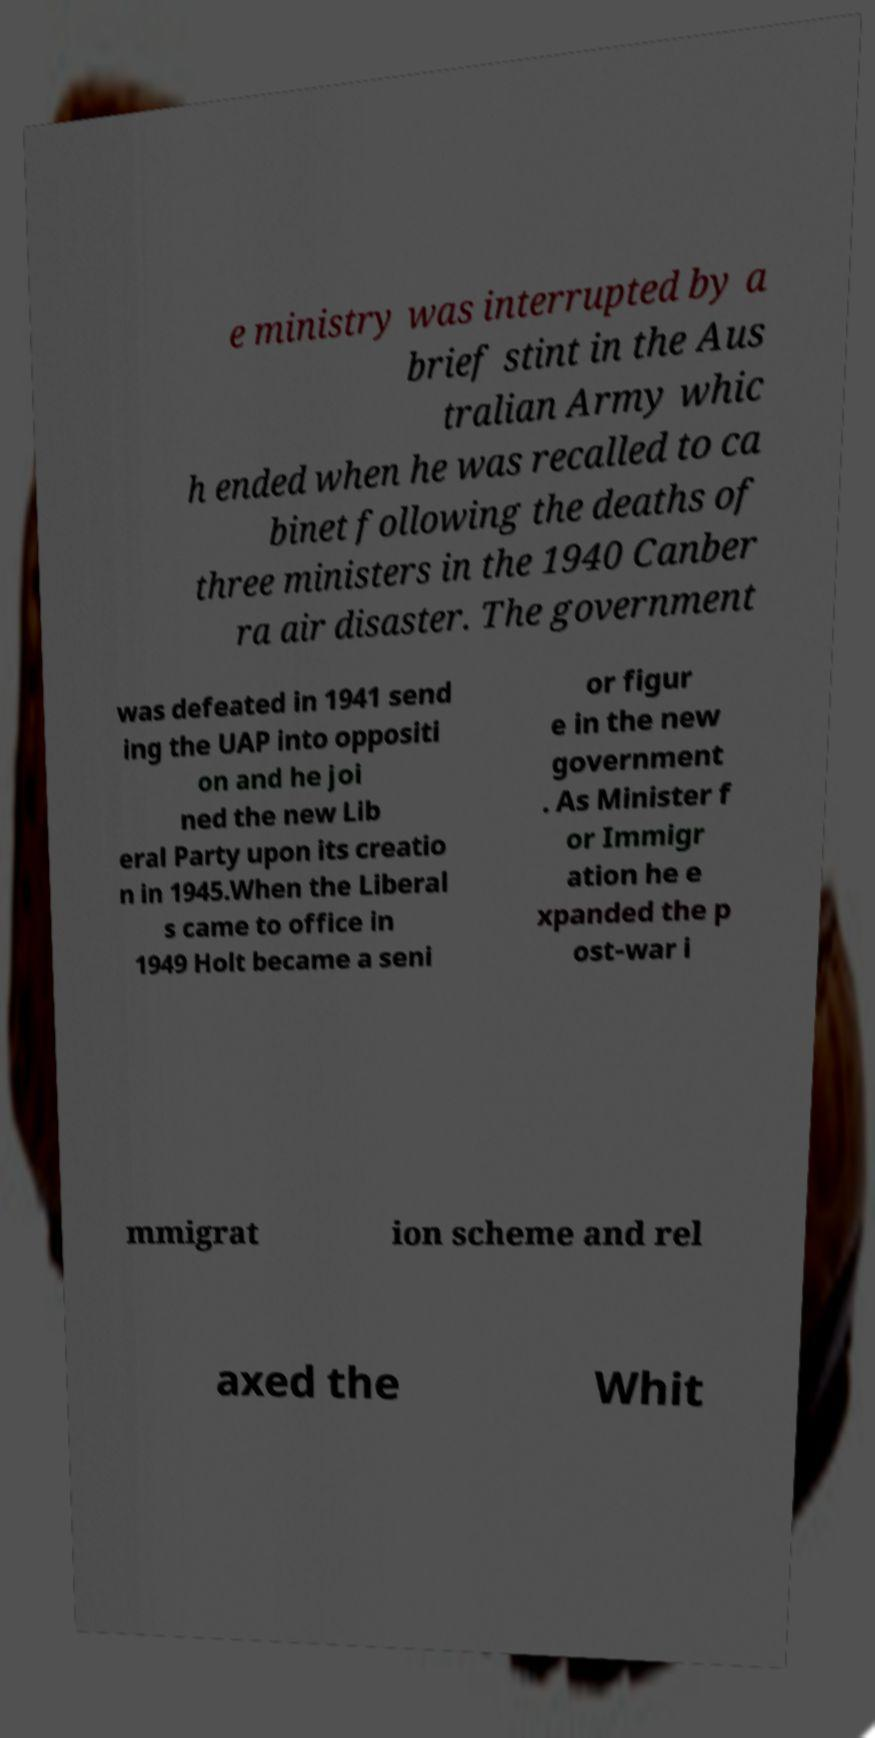Could you extract and type out the text from this image? e ministry was interrupted by a brief stint in the Aus tralian Army whic h ended when he was recalled to ca binet following the deaths of three ministers in the 1940 Canber ra air disaster. The government was defeated in 1941 send ing the UAP into oppositi on and he joi ned the new Lib eral Party upon its creatio n in 1945.When the Liberal s came to office in 1949 Holt became a seni or figur e in the new government . As Minister f or Immigr ation he e xpanded the p ost-war i mmigrat ion scheme and rel axed the Whit 